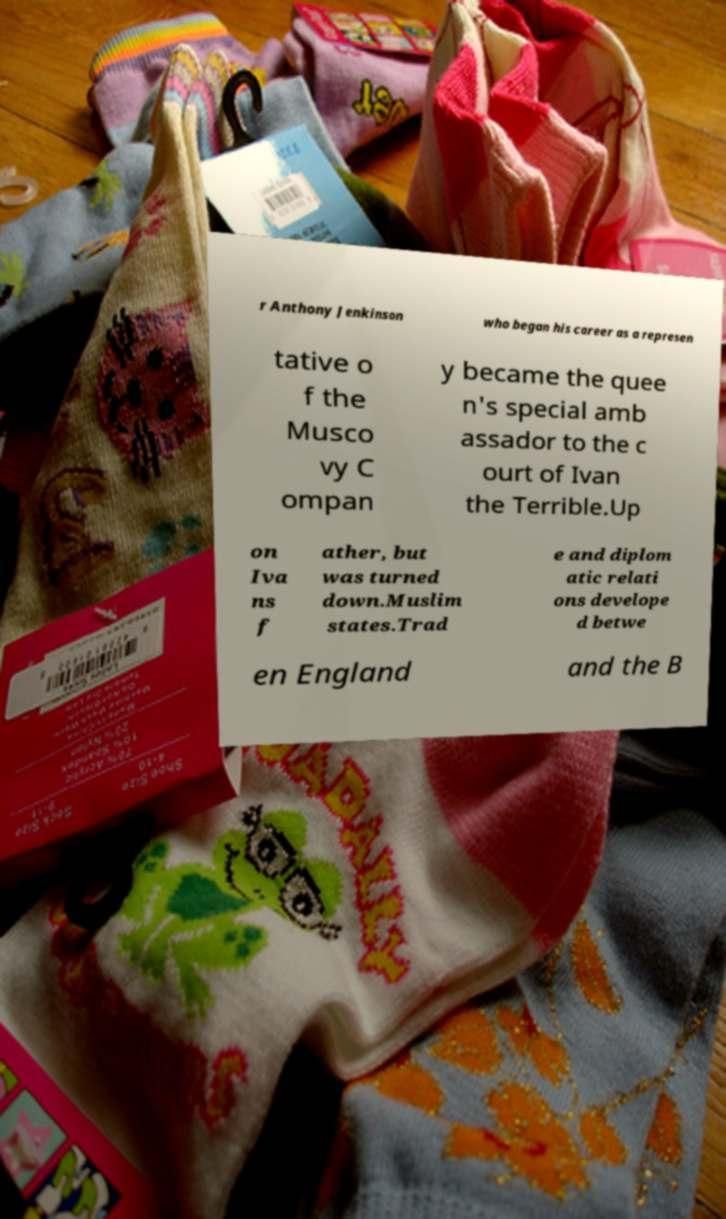There's text embedded in this image that I need extracted. Can you transcribe it verbatim? r Anthony Jenkinson who began his career as a represen tative o f the Musco vy C ompan y became the quee n's special amb assador to the c ourt of Ivan the Terrible.Up on Iva ns f ather, but was turned down.Muslim states.Trad e and diplom atic relati ons develope d betwe en England and the B 